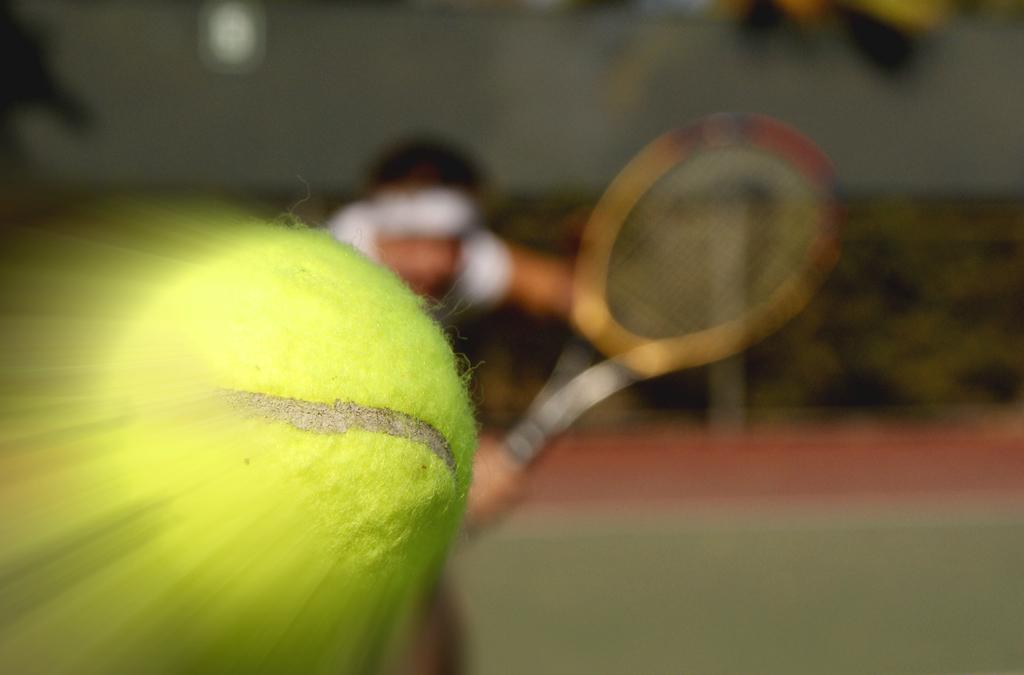Who is present in the image? There is a man in the image. What is the man doing in the image? The man is standing on the ground and holding a racket in his hands. What else can be seen in the image? There is a ball in the image. Can you describe the background of the image? The background of the image is blurry. What type of polish is the man applying to his nails in the image? There is no indication in the image that the man is applying any polish to his nails, as he is holding a racket and standing on the ground. 